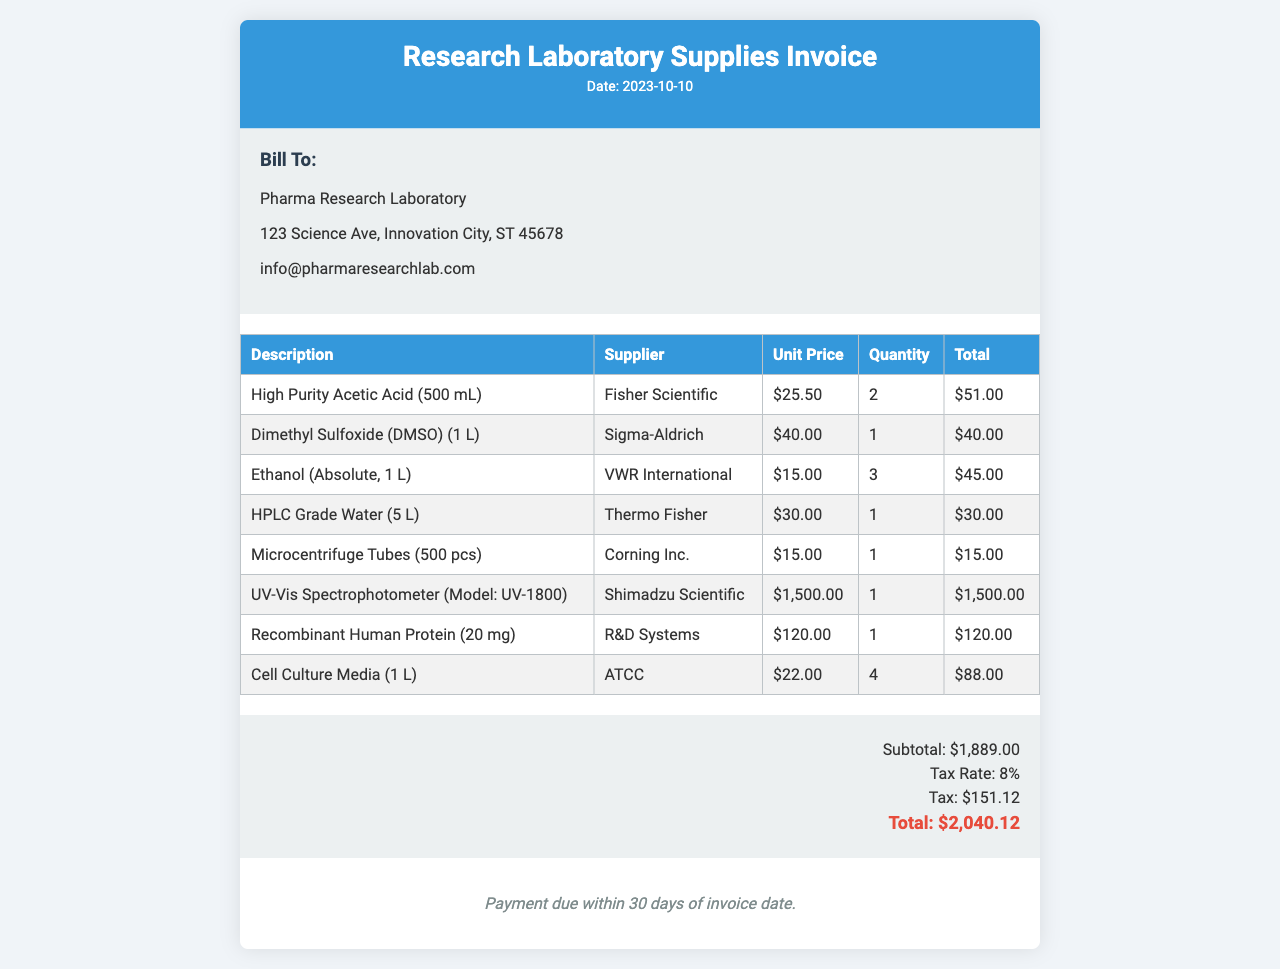what is the date of the invoice? The date of the invoice is clearly stated in the document header.
Answer: 2023-10-10 who is the supplier of the UV-Vis Spectrophotometer? The supplier for the UV-Vis Spectrophotometer is listed in the table of items.
Answer: Shimadzu Scientific what is the unit price of Dimethyl Sulfoxide (DMSO)? The unit price of Dimethyl Sulfoxide (DMSO) is provided in the items table.
Answer: $40.00 how many Microcentrifuge Tubes are included? The quantity of Microcentrifuge Tubes is mentioned in the items table under quantity.
Answer: 1 what is the subtotal amount before tax? The subtotal amount is clearly listed in the summary section of the invoice.
Answer: $1,889.00 what is the tax rate applied to the invoice? The tax rate is specified in the summary section of the document.
Answer: 8% what is the total amount due on this invoice? The total amount due is provided in the summary section, summarizing costs.
Answer: $2,040.12 what is the payment term for this invoice? The payment terms are mentioned in the payment terms section at the bottom of the invoice.
Answer: Payment due within 30 days of invoice date 